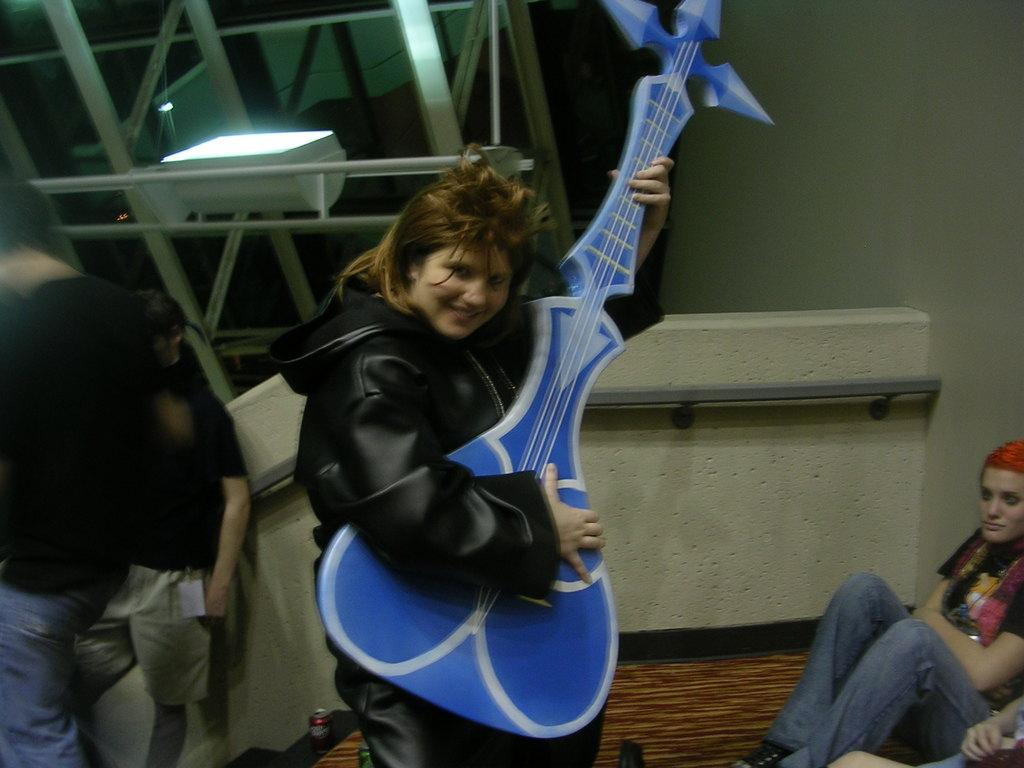What is present in the image that serves as a background or boundary? There is a wall in the image. What are the people in the image doing? The people in the image are standing and sitting. Can you describe the woman in the image? The woman in the image is standing and holding a guitar. What type of advice is the woman giving to the people in the image? There is no indication in the image that the woman is giving advice to anyone. Can you describe the arch in the image? There is no arch present in the image. What kind of beetle can be seen crawling on the wall in the image? There is no beetle present in the image. 